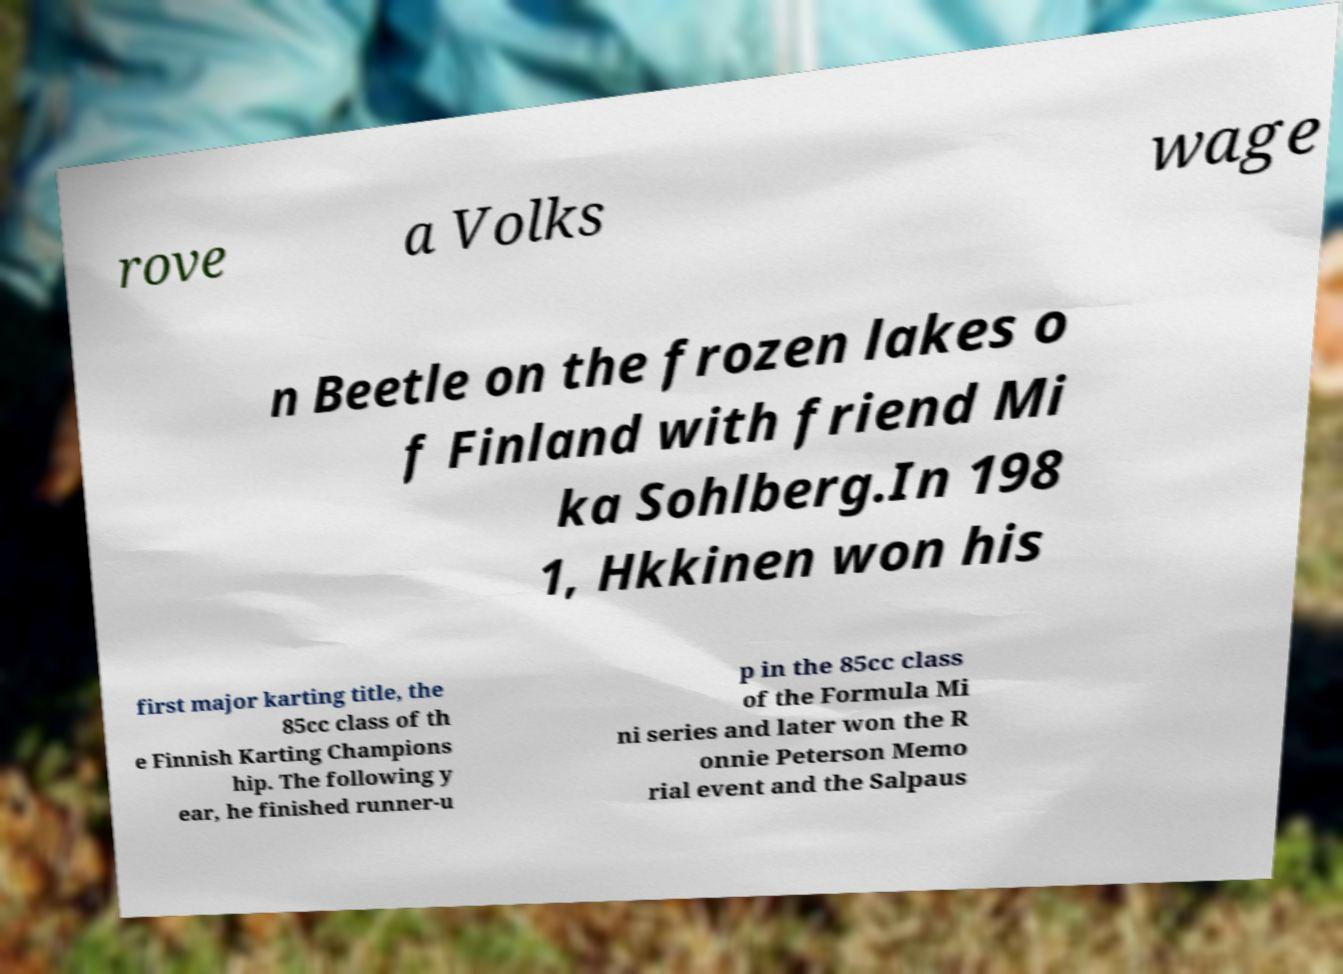Can you read and provide the text displayed in the image?This photo seems to have some interesting text. Can you extract and type it out for me? rove a Volks wage n Beetle on the frozen lakes o f Finland with friend Mi ka Sohlberg.In 198 1, Hkkinen won his first major karting title, the 85cc class of th e Finnish Karting Champions hip. The following y ear, he finished runner-u p in the 85cc class of the Formula Mi ni series and later won the R onnie Peterson Memo rial event and the Salpaus 